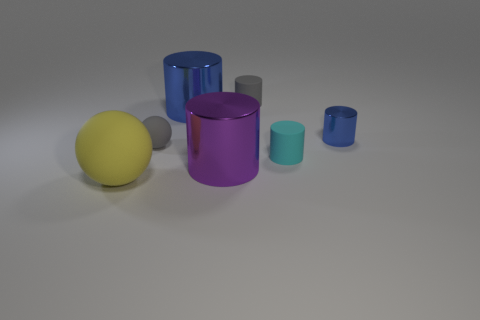There is a rubber object that is the same size as the purple metal cylinder; what is its shape?
Your response must be concise. Sphere. There is a small gray thing behind the shiny cylinder that is to the left of the purple cylinder; what number of purple metallic cylinders are behind it?
Your answer should be very brief. 0. Is the number of tiny matte objects behind the gray sphere greater than the number of big yellow balls behind the small metallic object?
Your response must be concise. Yes. How many other matte objects are the same shape as the purple thing?
Provide a succinct answer. 2. How many objects are either cyan matte cylinders to the right of the big rubber thing or rubber things behind the tiny shiny cylinder?
Your answer should be very brief. 2. The tiny gray thing that is on the right side of the rubber ball behind the big object on the left side of the tiny gray sphere is made of what material?
Keep it short and to the point. Rubber. There is a shiny thing behind the small blue thing; is it the same color as the small metallic cylinder?
Ensure brevity in your answer.  Yes. What material is the object that is both in front of the tiny sphere and on the right side of the gray rubber cylinder?
Your answer should be very brief. Rubber. Is there a purple cylinder of the same size as the cyan matte cylinder?
Provide a succinct answer. No. What number of red cylinders are there?
Your answer should be compact. 0. 